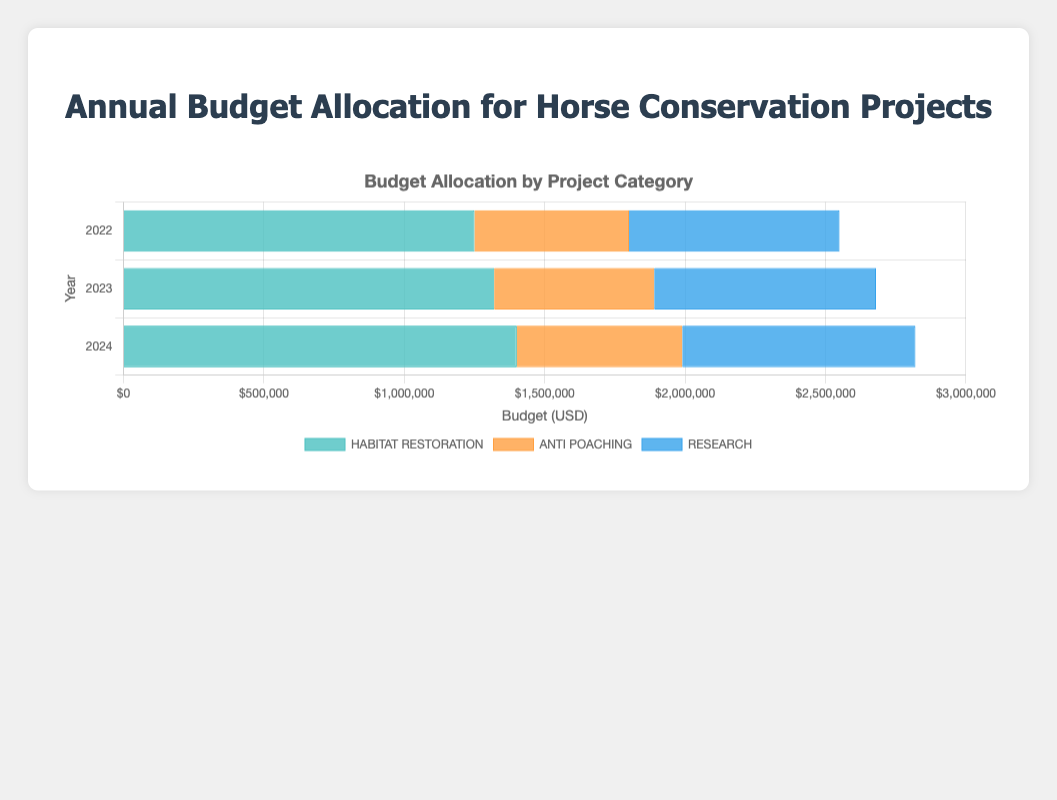### Question 1
 What was the total budget allocated for habitat restoration across all three years? To find the total budget for habitat restoration, sum the amounts for all relevant years. For 2022, it is \$500,000 (Wildlife Habitat Council) + \$750,000 (The Nature Conservancy) = \$1,250,000. For 2023, it is \$520,000 + \$800,000 = \$1,320,000. For 2024, it is \$550,000 + \$850,000 = \$1,400,000. Adding these totals: \$1,250,000 + \$1,320,000 + \$1,400,000 = \$3,970,000.
Answer: \$3,970,000 ### Question 2
Which year had the highest total budget for anti-poaching initiatives? Compare the total amounts for anti-poaching in all three years. For 2022, it is \$250,000 (World Wildlife Fund) + \$300,000 (International Anti-Poaching Foundation) = \$550,000. For 2023, it is \$260,000 + \$310,000 = \$570,000. For 2024, it is \$270,000 + \$320,000 = \$590,000. The highest is in 2024.
Answer: 2024 ### Question 3
What is the average annual budget allocated to research projects from 2022 to 2024? First, find the total amount for research each year. For 2022, it is \$400,000 (Equine Research Foundation) + \$350,000 (American Wild Horse Campaign) = \$750,000. For 2023, it is \$420,000 + \$370,000 = \$790,000. For 2024, it is \$440,000 + \$390,000 = \$830,000. Now sum these totals: \$750,000 + \$790,000 + \$830,000 = \$2,370,000. Divide by 3 to get the average: \$2,370,000 / 3 = \$790,000.
Answer: \$790,000 ### Question 4
Did the budget for habitat restoration increase, decrease or stay the same from 2023 to 2024? Compare the total habitat restoration budget for each year. For 2023, it is \$520,000 + \$800,000 = \$1,320,000 and for 2024, it is \$550,000 + \$850,000 = \$1,400,000. Clearly, it increased.
Answer: Increased ### Question 5
Which conservation project category saw the least amount of total funding across all three years? Sum up the total budgets for all categories. Habitat restoration: \$3,970,000, Anti-poaching: \$1,710,000 (i.e., \$550,000 + \$570,000 + \$590,000), Research: \$2,370,000. The least amount is for Anti-poaching, which is \$1,710,000.
Answer: Anti-poaching ### Question 6
How much more was allocated to research than to anti-poaching in 2024? First, find the totals for 2024 for both categories. Research gets \$440,000 (Equine Research Foundation) + \$390,000 (American Wild Horse Campaign) = \$830,000. Anti-poaching gets \$270,000 (World Wildlife Fund) + \$320,000 (International Anti-Poaching Foundation) = \$590,000. The difference is \$830,000 - \$590,000 = \$240,000.
Answer: \$240,000 ### Question 7
What was the budget for The Nature Conservancy in 2023? From the data, The Nature Conservancy had a budget of \$800,000 for habitat restoration in 2023.
Answer: \$800,000 ### Question 8
Visually, which category has the largest individual bar segment for any of the years? By examining the widths of the segments in the horizontal stacked bar chart, we can see that habitat restoration has the largest segments. Specifically, for habitat restoration in 2024 which is \$850,000 by The Nature Conservancy.
Answer: Habitat Restoration in 2024 ### Question 9
What was the combined total budget for the International Anti-Poaching Foundation across all three years? Sum the allocated amounts for each year: \$300,000 (2022) + \$310,000 (2023) + \$320,000 (2024) = \$930,000.
Answer: \$930,000 